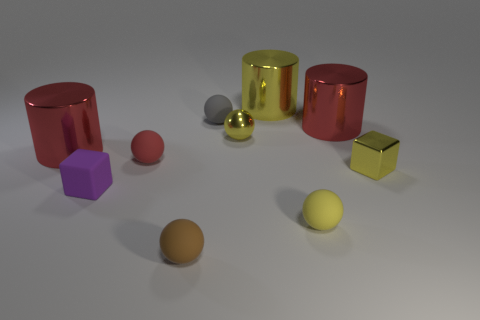How many yellow balls must be subtracted to get 1 yellow balls? 1 Subtract all metallic spheres. How many spheres are left? 4 Subtract all brown balls. How many balls are left? 4 Subtract all green balls. Subtract all brown cubes. How many balls are left? 5 Subtract all cubes. How many objects are left? 8 Add 8 yellow metallic cylinders. How many yellow metallic cylinders exist? 9 Subtract 1 purple blocks. How many objects are left? 9 Subtract all large blue matte cylinders. Subtract all large red things. How many objects are left? 8 Add 3 yellow metal blocks. How many yellow metal blocks are left? 4 